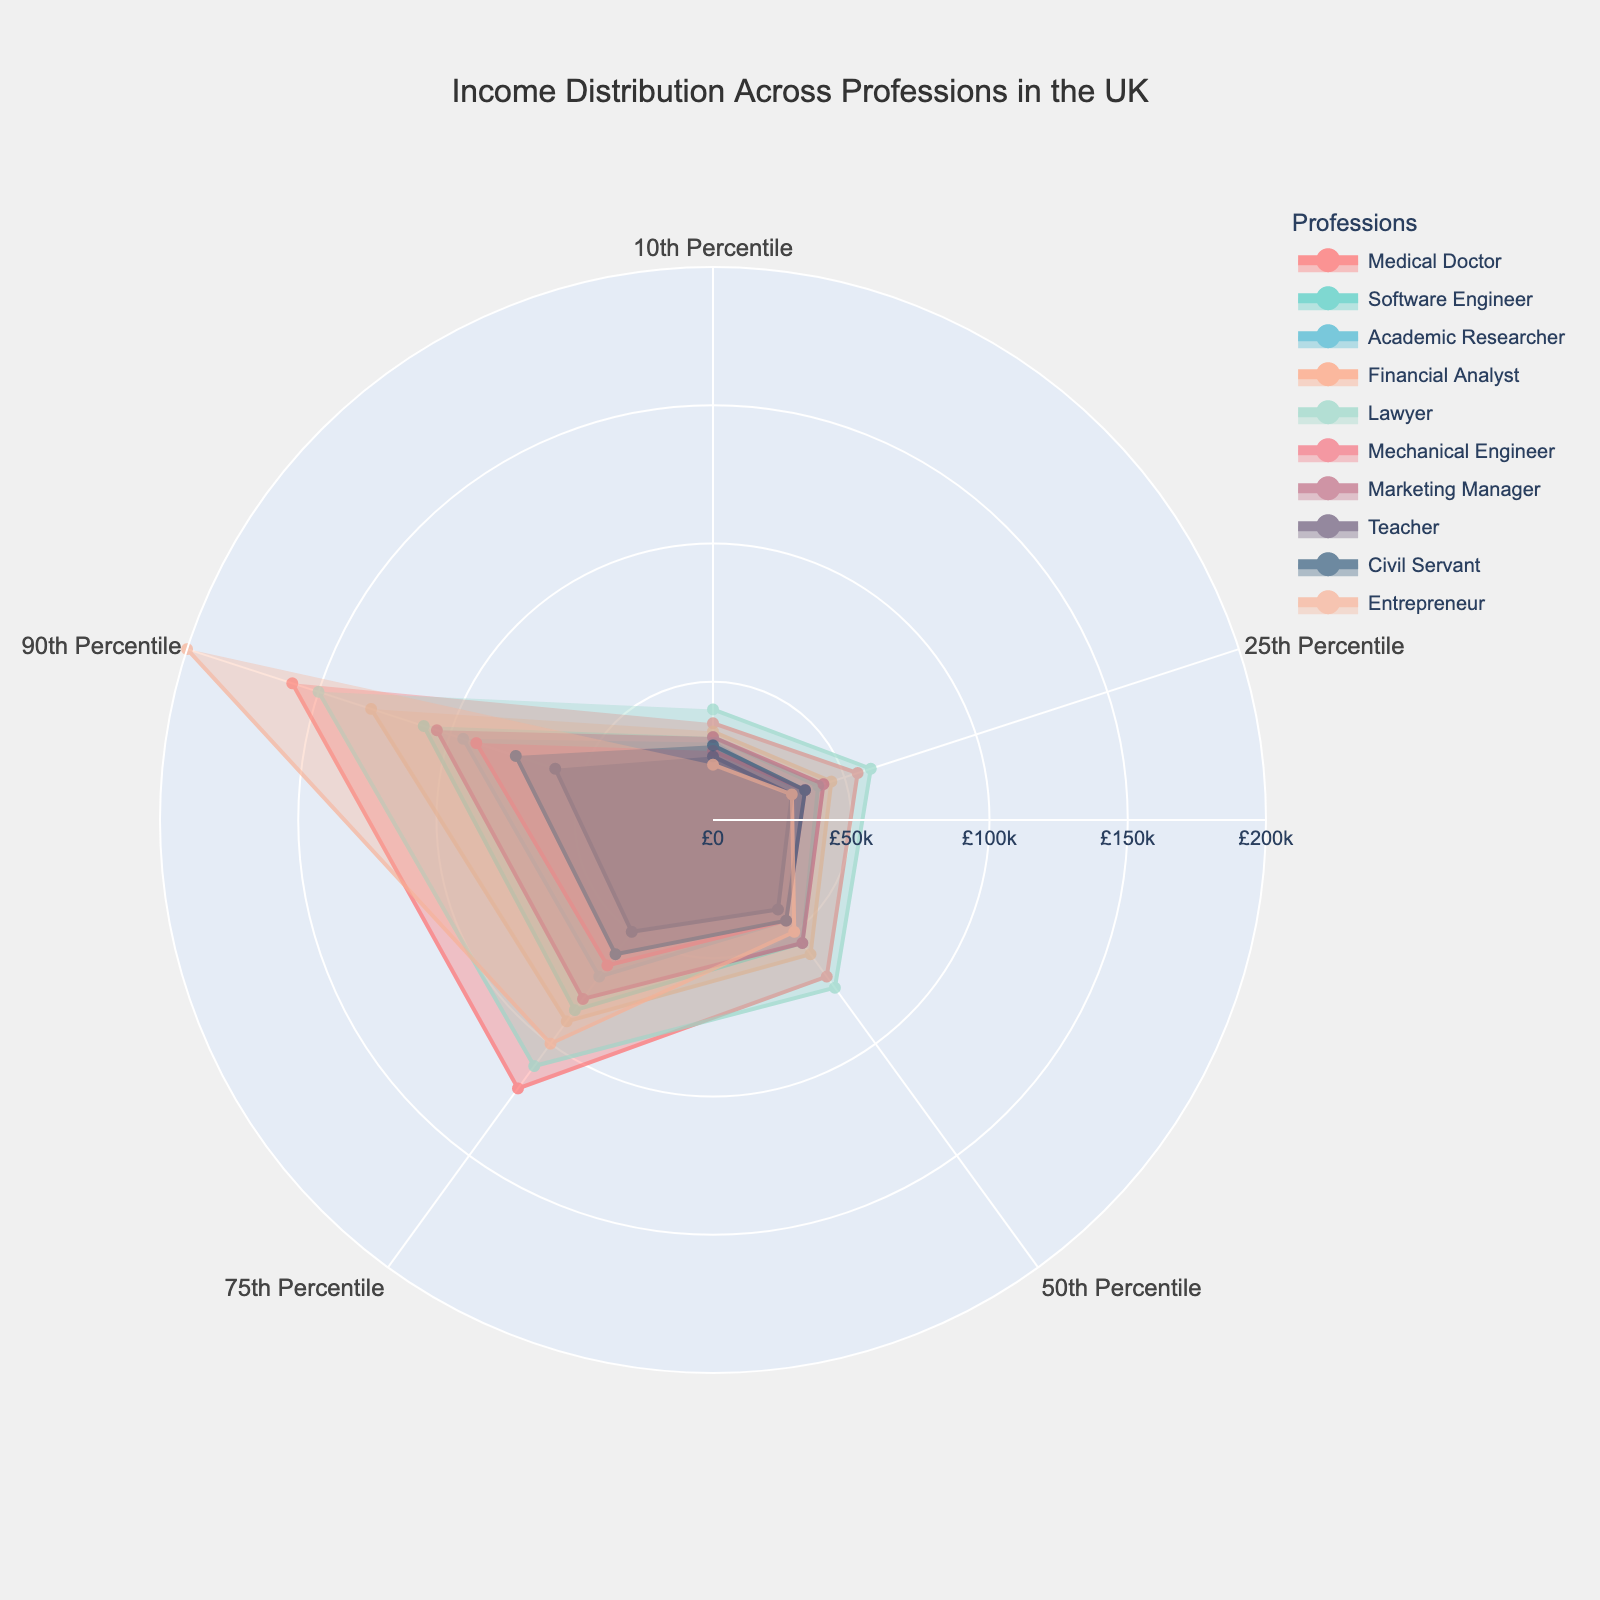What is the title of the radar chart? The title is specified at the top of the radar chart. By reading the chart, we can identify the title.
Answer: Income Distribution Across Professions in the UK Which profession has the highest income at the 90th percentile? By observing the 90th percentile values plotted on the radar chart, we can see which profession reaches the highest income.
Answer: Entrepreneur What is the income of a Medical Doctor at the 75th percentile? By locating the Medical Doctor trace on the radar chart and following it to the 75th percentile, we can identify the specific income value.
Answer: £120,000 How does the 90th percentile income of a Lawyer compare to that of a Financial Analyst? By comparing the 90th percentile markers of both the Lawyer and Financial Analyst traces, we can determine which is higher.
Answer: Lawyer's 90th percentile income is higher What is the median income for Academic Researchers and Teachers, and which is higher? Locate the median (50th percentile) for both Academic Researchers and Teachers on the chart and compare the values.
Answer: Academic Researcher's median income is higher Which profession has the lowest 10th percentile income, and what is its value? By examining the 10th percentile values for all professions on the radar chart, we can identify the lowest value and its corresponding profession.
Answer: Entrepreneur at £20,000 What is the range of incomes for Software Engineers at the 10th and 90th percentiles? Find the income values for Software Engineers at the 10th and 90th percentiles and calculate the difference.
Answer: Range is £80,000 How do the 75th percentile incomes of Mechanical Engineers and Civil Servants compare? Locate the 75th percentile incomes for both Mechanical Engineers and Civil Servants and compare the values.
Answer: Mechanical Engineer's 75th percentile income is higher What are the professions that have incomes over £90,000 at the 75th percentile? By observing the 75th percentile markers for all profession traces, identify those that exceed £90,000.
Answer: Medical Doctor, Financial Analyst, Lawyer, Entrepreneur Which profession has the narrowest income range between the 25th and 75th percentiles? Calculate the income range between the 25th and 75th percentiles for all professions, and identify the smallest range.
Answer: Teacher 